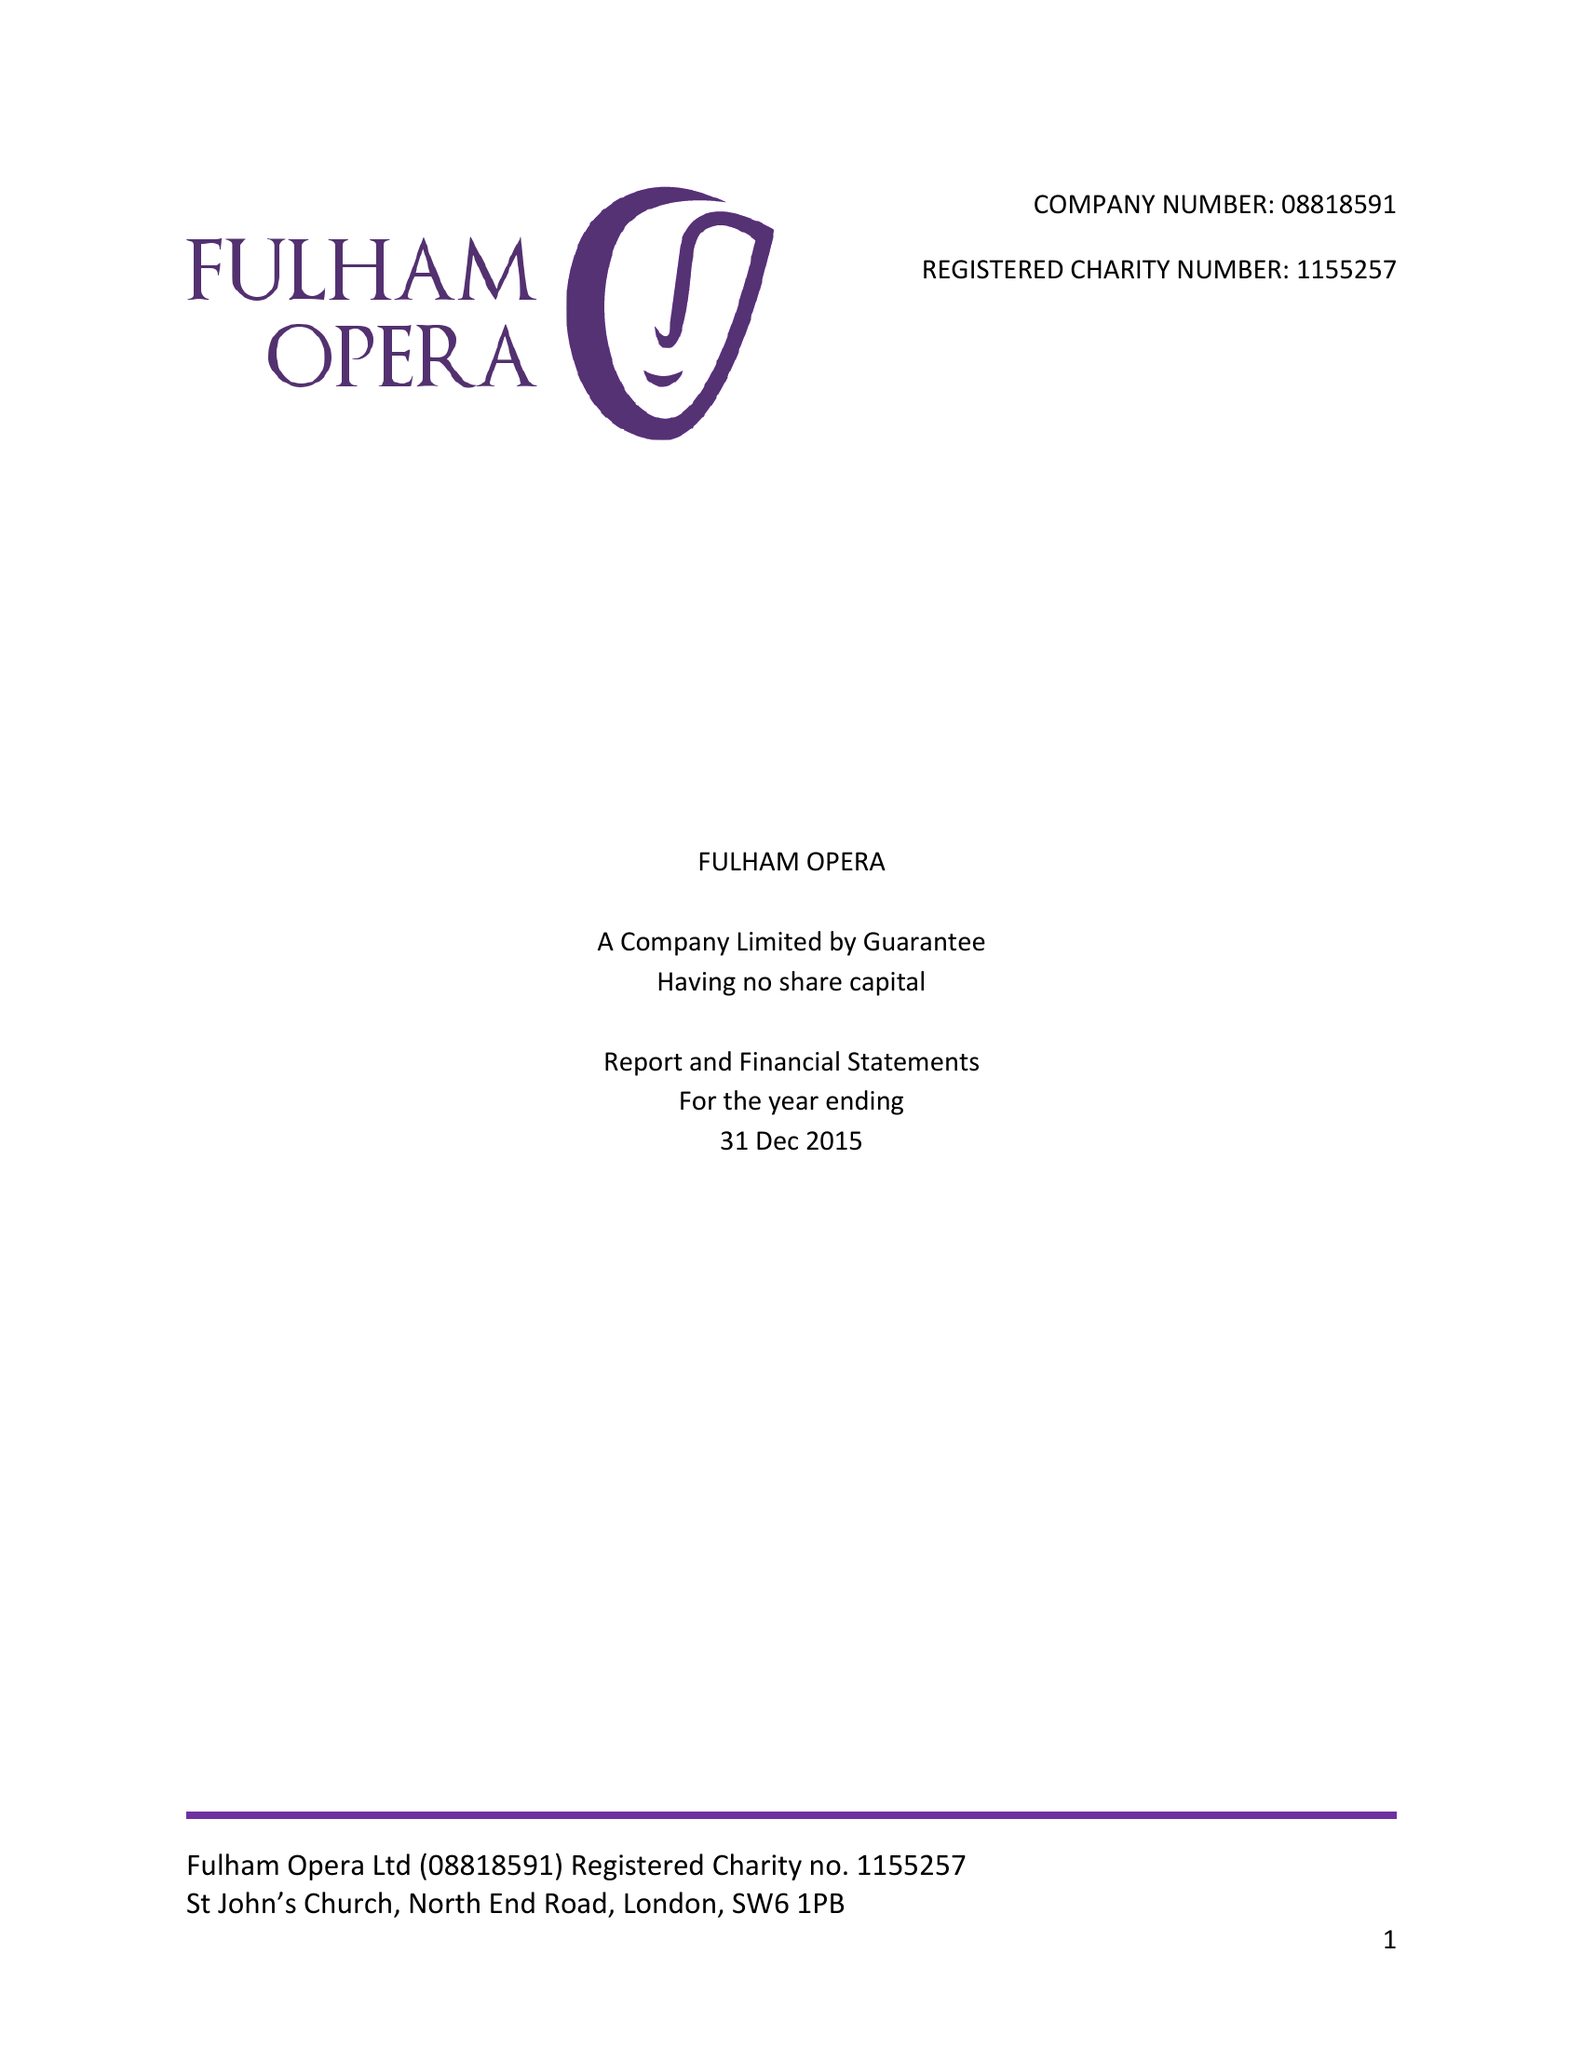What is the value for the charity_number?
Answer the question using a single word or phrase. 1155257 